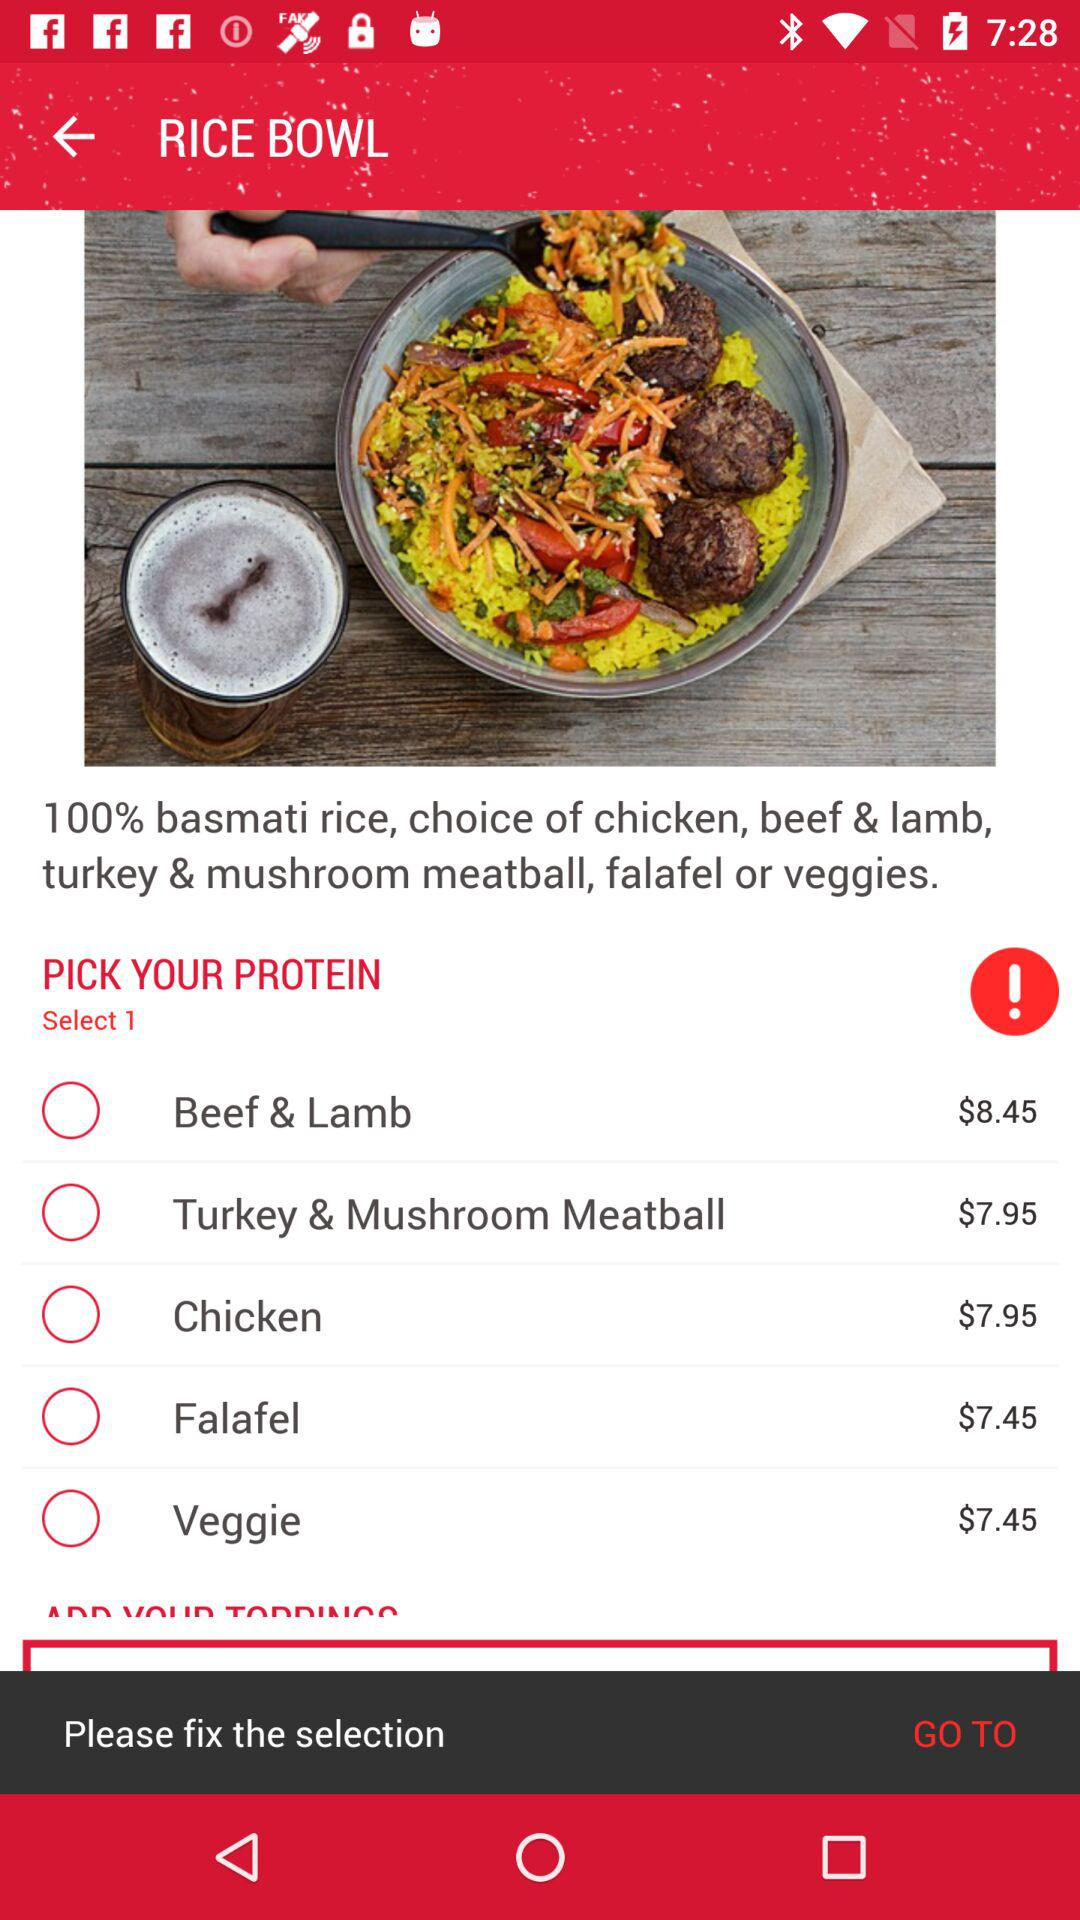What's the cost of "Falafel"? The cost is $7.45. 